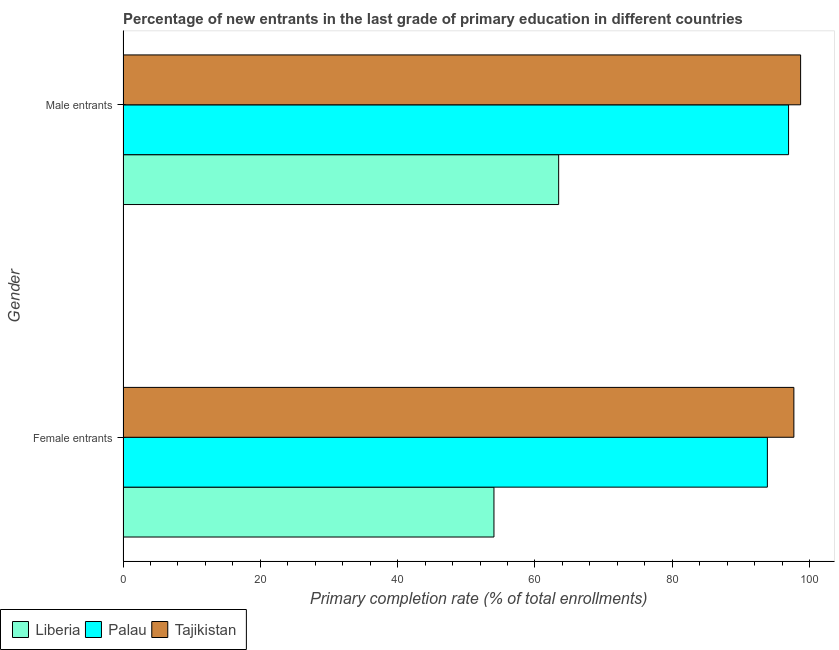How many different coloured bars are there?
Ensure brevity in your answer.  3. How many groups of bars are there?
Give a very brief answer. 2. How many bars are there on the 1st tick from the top?
Make the answer very short. 3. What is the label of the 1st group of bars from the top?
Offer a terse response. Male entrants. What is the primary completion rate of female entrants in Palau?
Make the answer very short. 93.86. Across all countries, what is the maximum primary completion rate of female entrants?
Provide a succinct answer. 97.72. Across all countries, what is the minimum primary completion rate of female entrants?
Provide a short and direct response. 54.03. In which country was the primary completion rate of female entrants maximum?
Your answer should be compact. Tajikistan. In which country was the primary completion rate of female entrants minimum?
Offer a terse response. Liberia. What is the total primary completion rate of female entrants in the graph?
Keep it short and to the point. 245.61. What is the difference between the primary completion rate of female entrants in Tajikistan and that in Palau?
Provide a short and direct response. 3.86. What is the difference between the primary completion rate of male entrants in Liberia and the primary completion rate of female entrants in Palau?
Offer a very short reply. -30.4. What is the average primary completion rate of male entrants per country?
Keep it short and to the point. 86.37. What is the difference between the primary completion rate of female entrants and primary completion rate of male entrants in Tajikistan?
Your answer should be very brief. -0.98. In how many countries, is the primary completion rate of female entrants greater than 56 %?
Give a very brief answer. 2. What is the ratio of the primary completion rate of female entrants in Tajikistan to that in Liberia?
Ensure brevity in your answer.  1.81. In how many countries, is the primary completion rate of male entrants greater than the average primary completion rate of male entrants taken over all countries?
Ensure brevity in your answer.  2. What does the 3rd bar from the top in Male entrants represents?
Your response must be concise. Liberia. What does the 1st bar from the bottom in Female entrants represents?
Your response must be concise. Liberia. How many bars are there?
Keep it short and to the point. 6. What is the difference between two consecutive major ticks on the X-axis?
Make the answer very short. 20. Does the graph contain any zero values?
Offer a terse response. No. Does the graph contain grids?
Keep it short and to the point. No. What is the title of the graph?
Your answer should be compact. Percentage of new entrants in the last grade of primary education in different countries. Does "Guinea" appear as one of the legend labels in the graph?
Give a very brief answer. No. What is the label or title of the X-axis?
Your response must be concise. Primary completion rate (% of total enrollments). What is the label or title of the Y-axis?
Offer a very short reply. Gender. What is the Primary completion rate (% of total enrollments) of Liberia in Female entrants?
Give a very brief answer. 54.03. What is the Primary completion rate (% of total enrollments) in Palau in Female entrants?
Make the answer very short. 93.86. What is the Primary completion rate (% of total enrollments) in Tajikistan in Female entrants?
Offer a very short reply. 97.72. What is the Primary completion rate (% of total enrollments) of Liberia in Male entrants?
Your answer should be very brief. 63.46. What is the Primary completion rate (% of total enrollments) of Palau in Male entrants?
Provide a succinct answer. 96.95. What is the Primary completion rate (% of total enrollments) of Tajikistan in Male entrants?
Provide a succinct answer. 98.7. Across all Gender, what is the maximum Primary completion rate (% of total enrollments) in Liberia?
Offer a terse response. 63.46. Across all Gender, what is the maximum Primary completion rate (% of total enrollments) in Palau?
Provide a succinct answer. 96.95. Across all Gender, what is the maximum Primary completion rate (% of total enrollments) of Tajikistan?
Ensure brevity in your answer.  98.7. Across all Gender, what is the minimum Primary completion rate (% of total enrollments) in Liberia?
Make the answer very short. 54.03. Across all Gender, what is the minimum Primary completion rate (% of total enrollments) of Palau?
Your answer should be compact. 93.86. Across all Gender, what is the minimum Primary completion rate (% of total enrollments) of Tajikistan?
Your answer should be very brief. 97.72. What is the total Primary completion rate (% of total enrollments) of Liberia in the graph?
Ensure brevity in your answer.  117.49. What is the total Primary completion rate (% of total enrollments) of Palau in the graph?
Your answer should be compact. 190.81. What is the total Primary completion rate (% of total enrollments) of Tajikistan in the graph?
Your response must be concise. 196.42. What is the difference between the Primary completion rate (% of total enrollments) of Liberia in Female entrants and that in Male entrants?
Your answer should be compact. -9.42. What is the difference between the Primary completion rate (% of total enrollments) of Palau in Female entrants and that in Male entrants?
Provide a short and direct response. -3.09. What is the difference between the Primary completion rate (% of total enrollments) of Tajikistan in Female entrants and that in Male entrants?
Provide a short and direct response. -0.98. What is the difference between the Primary completion rate (% of total enrollments) in Liberia in Female entrants and the Primary completion rate (% of total enrollments) in Palau in Male entrants?
Offer a terse response. -42.91. What is the difference between the Primary completion rate (% of total enrollments) of Liberia in Female entrants and the Primary completion rate (% of total enrollments) of Tajikistan in Male entrants?
Your response must be concise. -44.67. What is the difference between the Primary completion rate (% of total enrollments) of Palau in Female entrants and the Primary completion rate (% of total enrollments) of Tajikistan in Male entrants?
Your answer should be compact. -4.84. What is the average Primary completion rate (% of total enrollments) of Liberia per Gender?
Provide a succinct answer. 58.75. What is the average Primary completion rate (% of total enrollments) of Palau per Gender?
Keep it short and to the point. 95.4. What is the average Primary completion rate (% of total enrollments) of Tajikistan per Gender?
Provide a short and direct response. 98.21. What is the difference between the Primary completion rate (% of total enrollments) of Liberia and Primary completion rate (% of total enrollments) of Palau in Female entrants?
Make the answer very short. -39.83. What is the difference between the Primary completion rate (% of total enrollments) in Liberia and Primary completion rate (% of total enrollments) in Tajikistan in Female entrants?
Your response must be concise. -43.69. What is the difference between the Primary completion rate (% of total enrollments) of Palau and Primary completion rate (% of total enrollments) of Tajikistan in Female entrants?
Ensure brevity in your answer.  -3.86. What is the difference between the Primary completion rate (% of total enrollments) of Liberia and Primary completion rate (% of total enrollments) of Palau in Male entrants?
Ensure brevity in your answer.  -33.49. What is the difference between the Primary completion rate (% of total enrollments) in Liberia and Primary completion rate (% of total enrollments) in Tajikistan in Male entrants?
Offer a terse response. -35.24. What is the difference between the Primary completion rate (% of total enrollments) in Palau and Primary completion rate (% of total enrollments) in Tajikistan in Male entrants?
Your answer should be compact. -1.75. What is the ratio of the Primary completion rate (% of total enrollments) of Liberia in Female entrants to that in Male entrants?
Your response must be concise. 0.85. What is the ratio of the Primary completion rate (% of total enrollments) in Palau in Female entrants to that in Male entrants?
Your response must be concise. 0.97. What is the ratio of the Primary completion rate (% of total enrollments) in Tajikistan in Female entrants to that in Male entrants?
Your answer should be compact. 0.99. What is the difference between the highest and the second highest Primary completion rate (% of total enrollments) in Liberia?
Offer a terse response. 9.42. What is the difference between the highest and the second highest Primary completion rate (% of total enrollments) in Palau?
Your response must be concise. 3.09. What is the difference between the highest and the second highest Primary completion rate (% of total enrollments) in Tajikistan?
Provide a short and direct response. 0.98. What is the difference between the highest and the lowest Primary completion rate (% of total enrollments) of Liberia?
Keep it short and to the point. 9.42. What is the difference between the highest and the lowest Primary completion rate (% of total enrollments) in Palau?
Provide a succinct answer. 3.09. What is the difference between the highest and the lowest Primary completion rate (% of total enrollments) in Tajikistan?
Your answer should be compact. 0.98. 